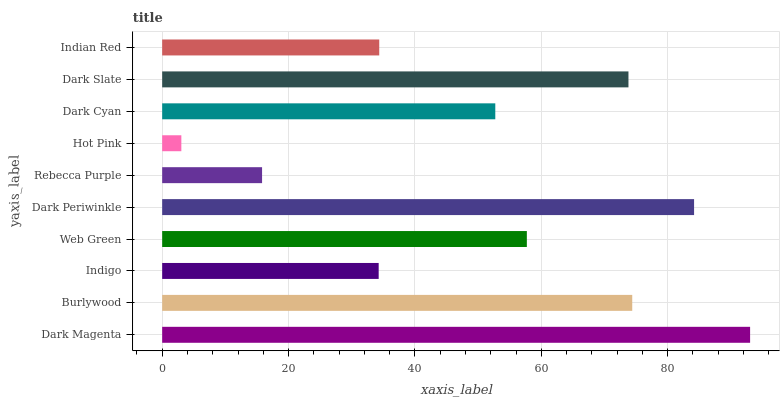Is Hot Pink the minimum?
Answer yes or no. Yes. Is Dark Magenta the maximum?
Answer yes or no. Yes. Is Burlywood the minimum?
Answer yes or no. No. Is Burlywood the maximum?
Answer yes or no. No. Is Dark Magenta greater than Burlywood?
Answer yes or no. Yes. Is Burlywood less than Dark Magenta?
Answer yes or no. Yes. Is Burlywood greater than Dark Magenta?
Answer yes or no. No. Is Dark Magenta less than Burlywood?
Answer yes or no. No. Is Web Green the high median?
Answer yes or no. Yes. Is Dark Cyan the low median?
Answer yes or no. Yes. Is Dark Cyan the high median?
Answer yes or no. No. Is Dark Periwinkle the low median?
Answer yes or no. No. 